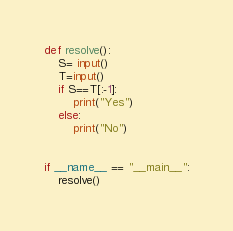<code> <loc_0><loc_0><loc_500><loc_500><_Python_>def resolve():
    S= input()
    T=input()
    if S==T[:-1]:
        print("Yes")
    else:
        print("No")


if __name__ == "__main__":
    resolve()</code> 